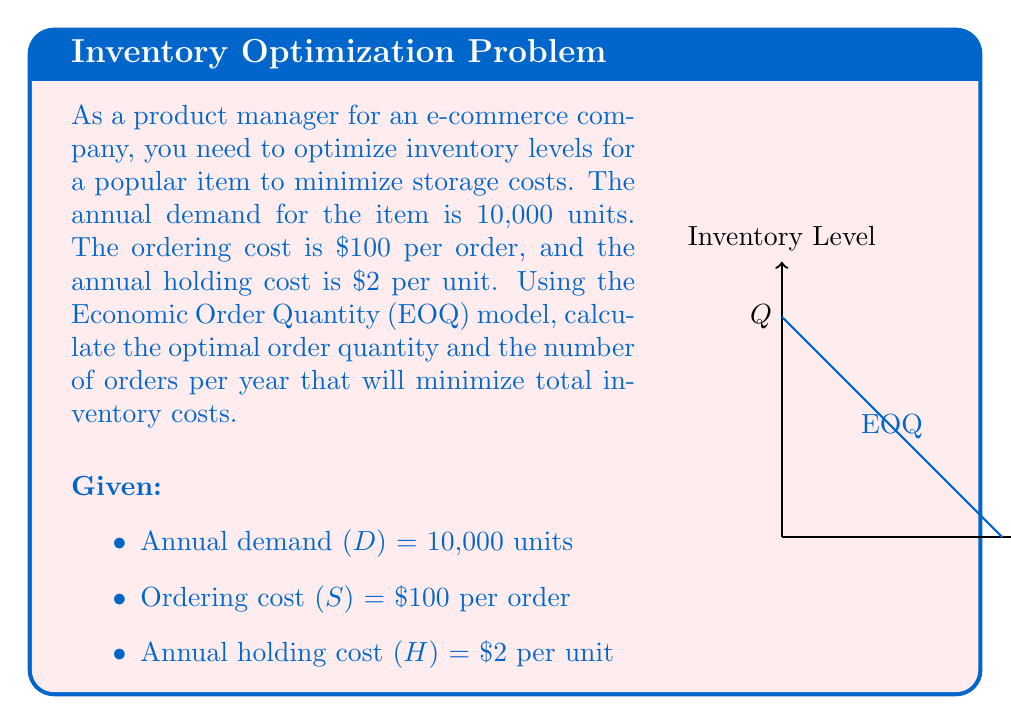Teach me how to tackle this problem. To solve this problem, we'll use the Economic Order Quantity (EOQ) model, which balances ordering costs and holding costs to minimize total inventory costs. The formula for EOQ is:

$$ EOQ = Q^* = \sqrt{\frac{2DS}{H}} $$

Where:
- $Q^*$ is the optimal order quantity
- $D$ is the annual demand
- $S$ is the ordering cost per order
- $H$ is the annual holding cost per unit

Step 1: Substitute the given values into the EOQ formula:

$$ Q^* = \sqrt{\frac{2 \cdot 10,000 \cdot 100}{2}} $$

Step 2: Simplify the expression under the square root:

$$ Q^* = \sqrt{1,000,000} $$

Step 3: Calculate the square root:

$$ Q^* = 1,000 \text{ units} $$

Step 4: Calculate the number of orders per year:

Number of orders = Annual demand / Optimal order quantity
$$ N = \frac{D}{Q^*} = \frac{10,000}{1,000} = 10 \text{ orders per year} $$

Therefore, the optimal order quantity is 1,000 units, and the company should place 10 orders per year to minimize total inventory costs.
Answer: EOQ = 1,000 units; 10 orders per year 